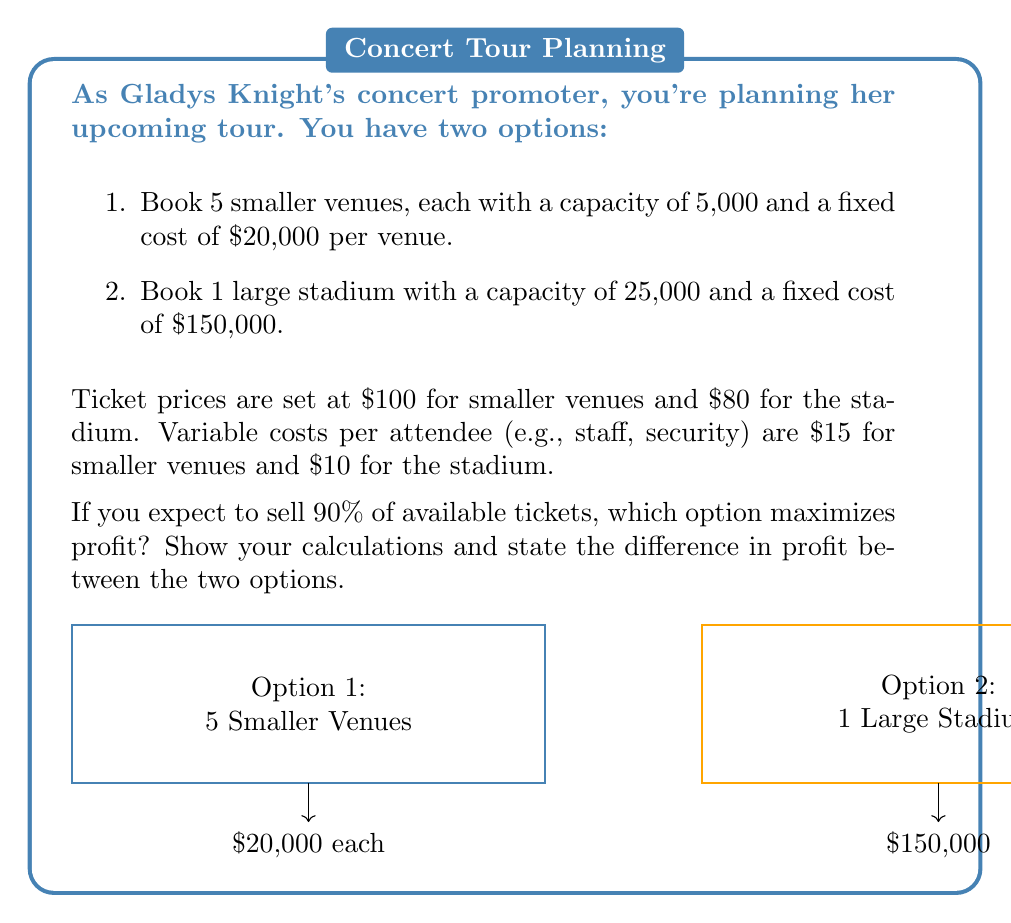What is the answer to this math problem? Let's break this down step-by-step:

1. Calculate the number of tickets sold for each option:
   Option 1: 5 venues × 5,000 capacity × 90% = 22,500 tickets
   Option 2: 1 stadium × 25,000 capacity × 90% = 22,500 tickets

2. Calculate revenue for each option:
   Option 1: 22,500 tickets × $100 = $2,250,000
   Option 2: 22,500 tickets × $80 = $1,800,000

3. Calculate fixed costs:
   Option 1: 5 venues × $20,000 = $100,000
   Option 2: $150,000

4. Calculate variable costs:
   Option 1: 22,500 attendees × $15 = $337,500
   Option 2: 22,500 attendees × $10 = $225,000

5. Calculate total costs:
   Option 1: $100,000 + $337,500 = $437,500
   Option 2: $150,000 + $225,000 = $375,000

6. Calculate profit for each option:
   Option 1: $2,250,000 - $437,500 = $1,812,500
   Option 2: $1,800,000 - $375,000 = $1,425,000

7. Compare profits:
   Difference in profit = $1,812,500 - $1,425,000 = $387,500

The mathematical representation of profit for each option:

Option 1: $$\pi_1 = 22500 \cdot 100 - (5 \cdot 20000 + 22500 \cdot 15) = 1812500$$

Option 2: $$\pi_2 = 22500 \cdot 80 - (150000 + 22500 \cdot 10) = 1425000$$

Therefore, Option 1 (booking 5 smaller venues) maximizes profit, yielding $387,500 more than Option 2.
Answer: Option 1 (5 smaller venues) maximizes profit by $387,500. 